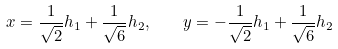<formula> <loc_0><loc_0><loc_500><loc_500>x = \frac { 1 } { \sqrt { 2 } } h _ { 1 } + \frac { 1 } { \sqrt { 6 } } h _ { 2 } , \quad y = - \frac { 1 } { \sqrt { 2 } } h _ { 1 } + \frac { 1 } { \sqrt { 6 } } h _ { 2 }</formula> 